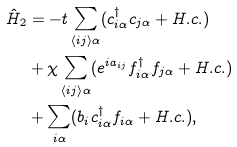Convert formula to latex. <formula><loc_0><loc_0><loc_500><loc_500>\hat { H } _ { 2 } & = - t \sum _ { \left < i j \right > \alpha } ( c _ { i \alpha } ^ { \dagger } c _ { j \alpha } + H . c . ) \\ & + \chi \sum _ { \left < i j \right > \alpha } ( e ^ { i a _ { i j } } f _ { i \alpha } ^ { \dagger } f _ { j \alpha } + H . c . ) \\ & + \sum _ { i \alpha } ( b _ { i } c _ { i \alpha } ^ { \dagger } f _ { i \alpha } + H . c . ) ,</formula> 